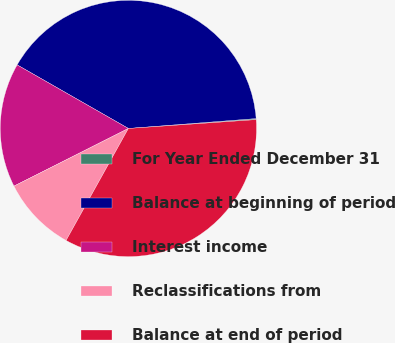Convert chart. <chart><loc_0><loc_0><loc_500><loc_500><pie_chart><fcel>For Year Ended December 31<fcel>Balance at beginning of period<fcel>Interest income<fcel>Reclassifications from<fcel>Balance at end of period<nl><fcel>0.13%<fcel>40.5%<fcel>15.69%<fcel>9.49%<fcel>34.18%<nl></chart> 